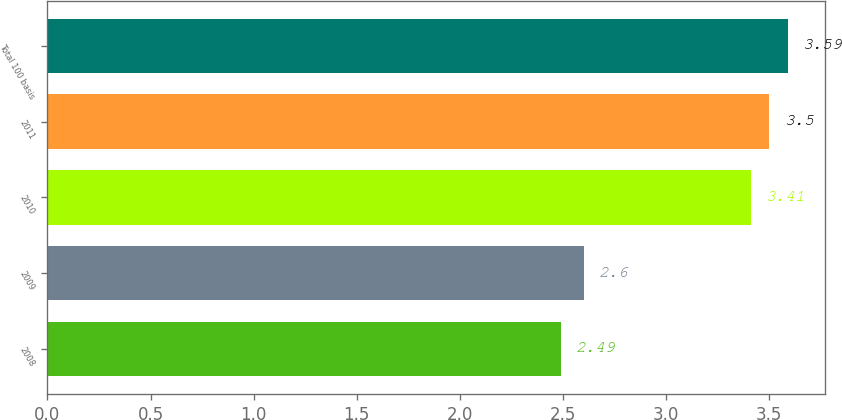Convert chart. <chart><loc_0><loc_0><loc_500><loc_500><bar_chart><fcel>2008<fcel>2009<fcel>2010<fcel>2011<fcel>Total 100 basis<nl><fcel>2.49<fcel>2.6<fcel>3.41<fcel>3.5<fcel>3.59<nl></chart> 